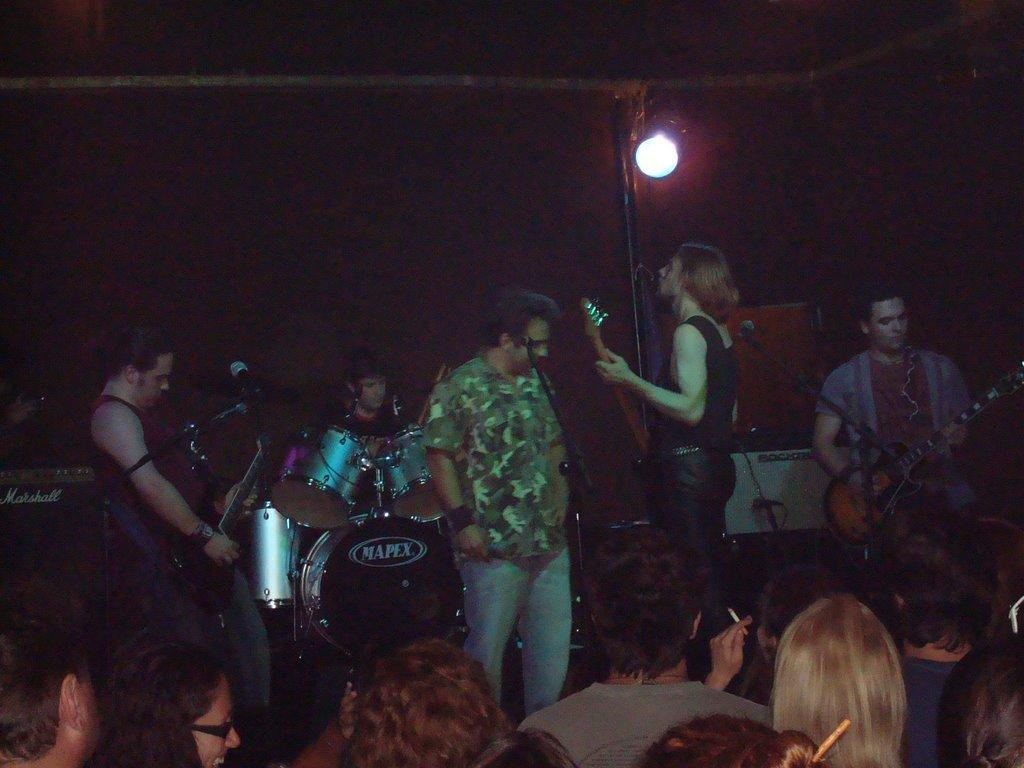How many people are in the image? There are people in the image, but the exact number is not specified. What are the people doing in the image? The people are standing and holding guitars in their hands. Is there any other musical instrument being played in the image? Yes, there is a man in the image playing drums. What type of pickle is being used as a drumstick in the image? There is no pickle present in the image, and the man playing drums is not using a pickle as a drumstick. What type of business is being conducted in the image? The image does not depict any business activities; it features people playing musical instruments. 